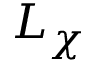<formula> <loc_0><loc_0><loc_500><loc_500>L _ { \chi }</formula> 